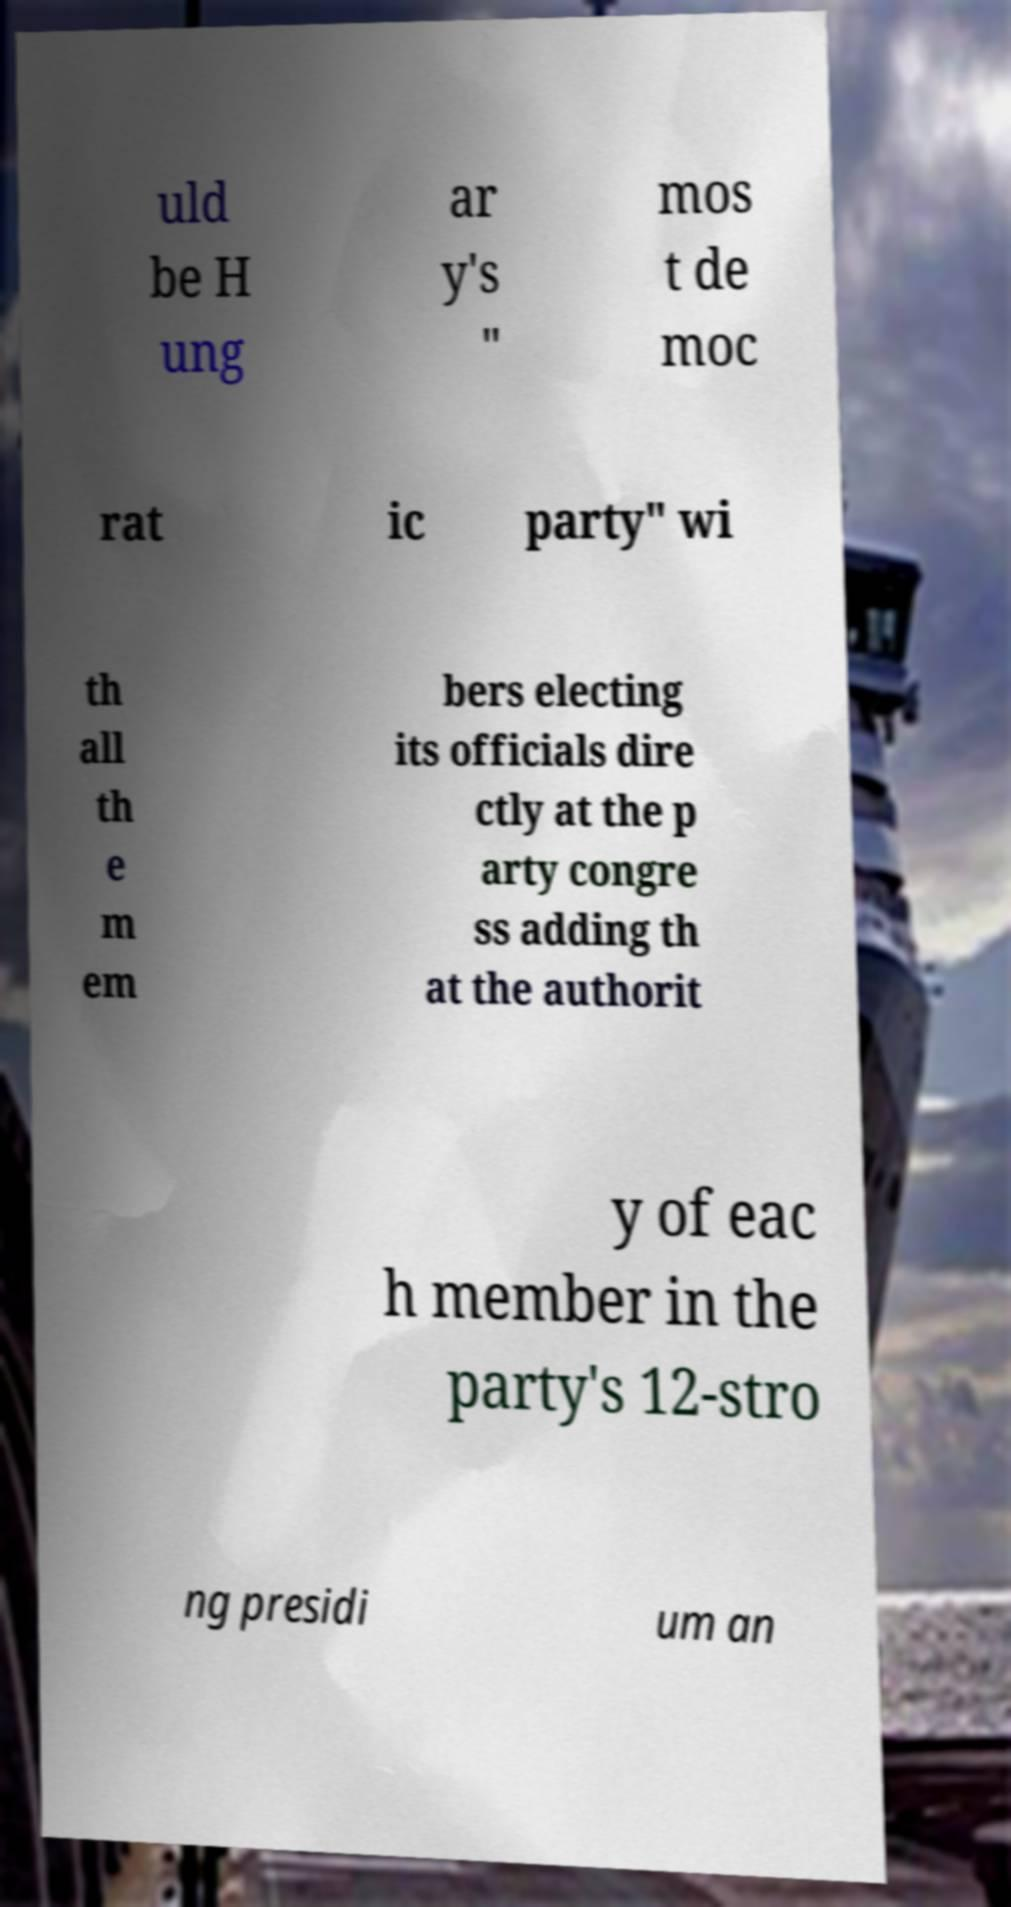Could you assist in decoding the text presented in this image and type it out clearly? uld be H ung ar y's " mos t de moc rat ic party" wi th all th e m em bers electing its officials dire ctly at the p arty congre ss adding th at the authorit y of eac h member in the party's 12-stro ng presidi um an 